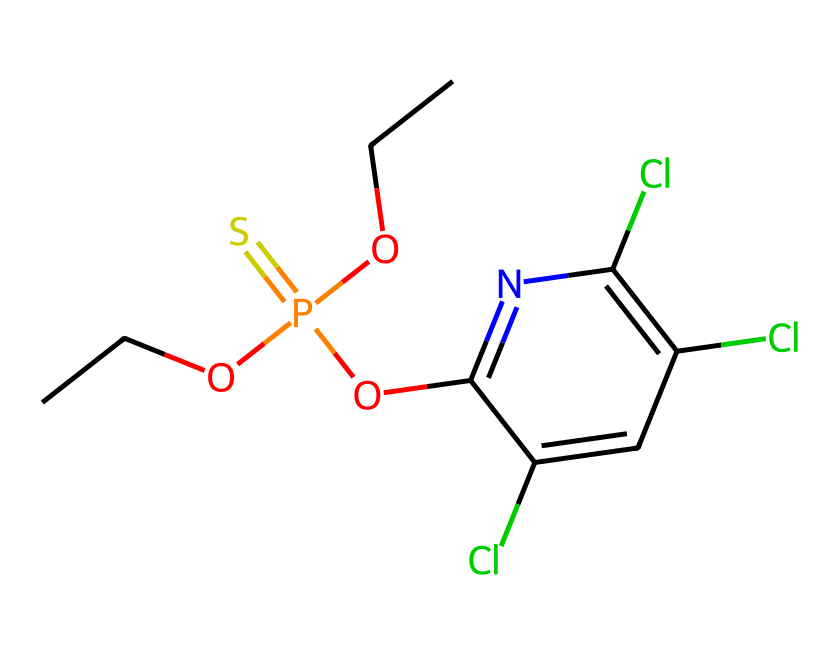What is the molecular formula of chlorpyrifos? To find the molecular formula, count the number of each type of atom in the SMILES representation. The elements represented are carbon (C), hydrogen (H), oxygen (O), phosphorus (P), sulfur (S), chlorine (Cl), and nitrogen (N). Counting the atoms gives: C: 9, H: 10, Cl: 3, N: 1, O: 2, P: 1, S: 1. Thus, the molecular formula is C9H10Cl3N1O2P1S1.
Answer: C9H10Cl3NO2PS How many chlorine atoms are present in chlorpyrifos? The SMILES representation includes the symbol "Cl" three times, indicating the presence of three chlorine atoms in the molecule.
Answer: 3 What functional groups are present in chlorpyrifos? The SMILES contains multiple parts showing different functional groups. Specifically, the presence of "O" and "P(=S)" indicates both an alkyl phosphate and an ether functional group. Therefore, chlorpyrifos has an alkyl phosphate and ether functional group.
Answer: alkyl phosphate, ether What is the significance of the phosphorus atom in chlorpyrifos? The phosphorus atom is critical in determining the chemical's activity as a pesticide. Pesticides that contain phosphorus often act as inhibitors of certain enzymatic processes in pests, hence contributing to their efficacy. The presence of a phosphorus atom indicates that this molecule is part of the organophosphate class of pesticides.
Answer: organophosphate How many total atoms are in the chlorpyrifos molecule? To determine the total number of atoms, we add up all the different atoms identified from the molecular formula: C(9) + H(10) + Cl(3) + N(1) + O(2) + P(1) + S(1) = 27 total atoms in the molecule.
Answer: 27 